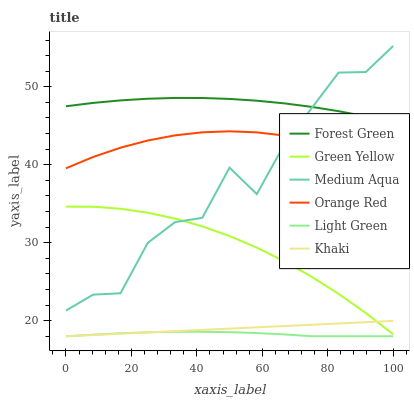Does Medium Aqua have the minimum area under the curve?
Answer yes or no. No. Does Medium Aqua have the maximum area under the curve?
Answer yes or no. No. Is Forest Green the smoothest?
Answer yes or no. No. Is Forest Green the roughest?
Answer yes or no. No. Does Medium Aqua have the lowest value?
Answer yes or no. No. Does Forest Green have the highest value?
Answer yes or no. No. Is Khaki less than Orange Red?
Answer yes or no. Yes. Is Forest Green greater than Green Yellow?
Answer yes or no. Yes. Does Khaki intersect Orange Red?
Answer yes or no. No. 